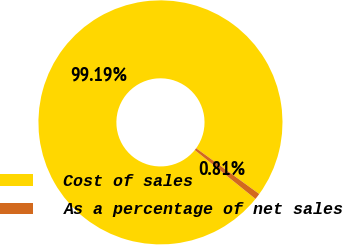Convert chart. <chart><loc_0><loc_0><loc_500><loc_500><pie_chart><fcel>Cost of sales<fcel>As a percentage of net sales<nl><fcel>99.19%<fcel>0.81%<nl></chart> 